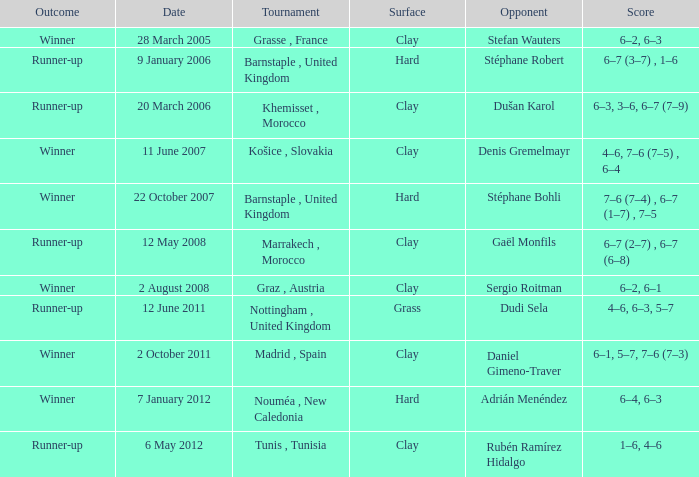What was the result on the 2nd of october, 2011? 6–1, 5–7, 7–6 (7–3). 